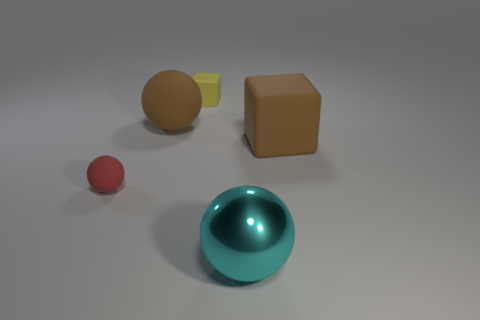There is a big matte object on the right side of the matte cube that is on the left side of the big object that is in front of the red sphere; what shape is it?
Provide a short and direct response. Cube. Is there any other thing that is the same shape as the metal thing?
Offer a very short reply. Yes. How many spheres are large cyan shiny objects or tiny yellow things?
Ensure brevity in your answer.  1. There is a large sphere that is behind the tiny red thing; is it the same color as the large rubber cube?
Provide a succinct answer. Yes. What is the sphere that is on the right side of the small object that is right of the matte ball that is to the right of the red rubber ball made of?
Provide a succinct answer. Metal. Do the red thing and the brown block have the same size?
Ensure brevity in your answer.  No. Does the big rubber ball have the same color as the large matte object right of the big metal sphere?
Keep it short and to the point. Yes. The red object that is made of the same material as the yellow object is what shape?
Your answer should be compact. Sphere. Do the large thing that is in front of the small red rubber thing and the tiny red object have the same shape?
Give a very brief answer. Yes. How big is the cube that is behind the big thing that is on the left side of the large metallic object?
Offer a very short reply. Small. 